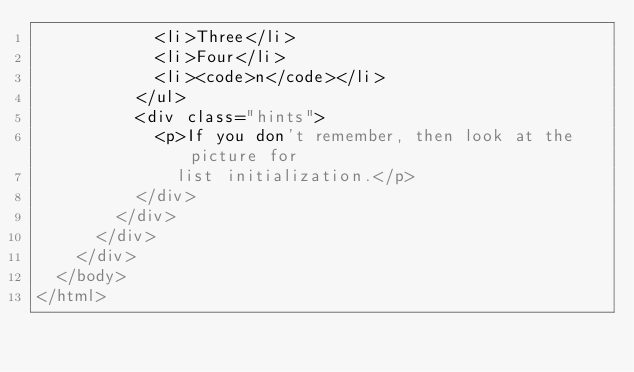Convert code to text. <code><loc_0><loc_0><loc_500><loc_500><_HTML_>            <li>Three</li>
            <li>Four</li>
            <li><code>n</code></li>
          </ul>
          <div class="hints">
            <p>If you don't remember, then look at the picture for
              list initialization.</p>
          </div>
        </div>
      </div>
    </div>
  </body>
</html>
</code> 